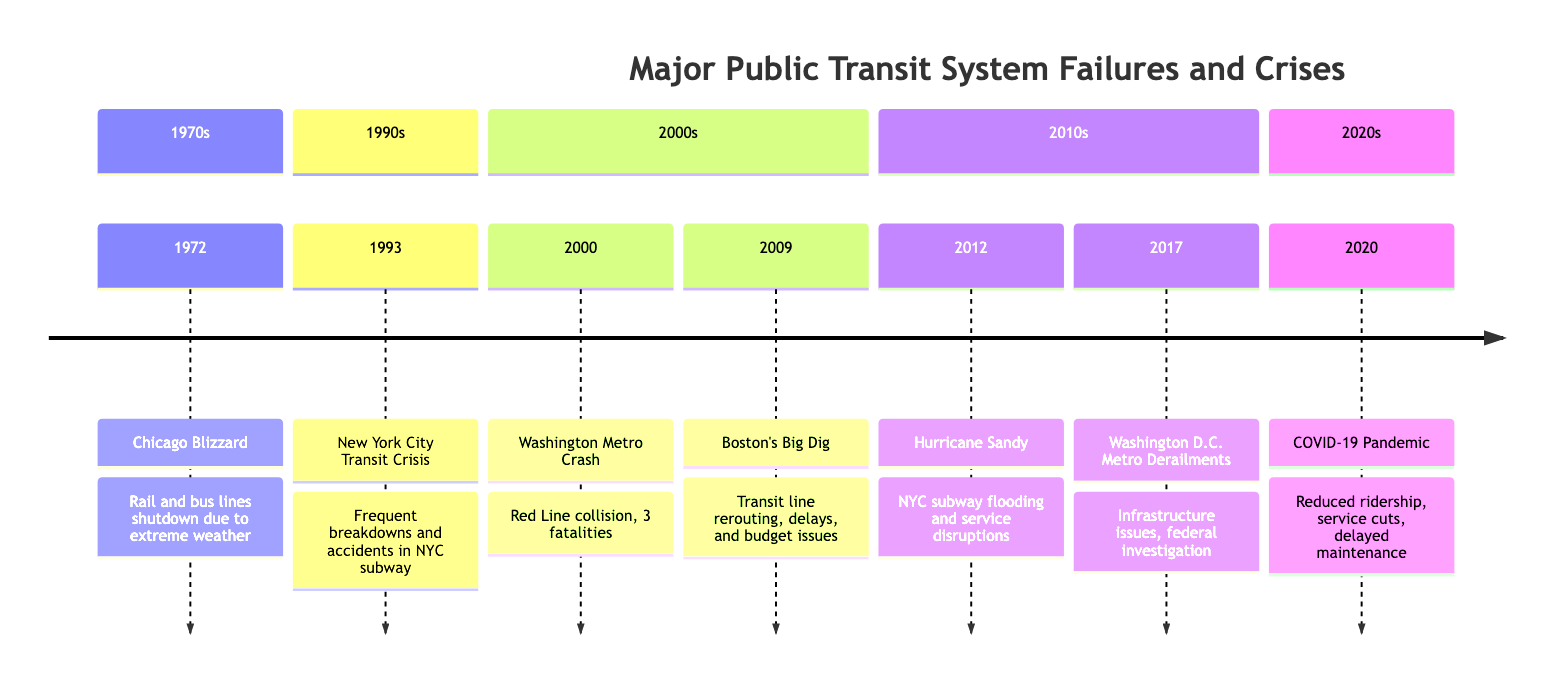What event occurred in 1972? The diagram shows that the event in 1972 is the Chicago Blizzard. This can be directly identified from the timeline as the first entry listed.
Answer: Chicago Blizzard What crisis happened in New York City in 1993? In 1993, the timeline specifies the New York City Transit Crisis. This event is clearly labeled in the timeline for that year.
Answer: New York City Transit Crisis How many fatalities were reported in the 2000 Washington Metro Crash? The event in 2000 details that there were three fatalities due to the Washington Metro Crash, which is directly stated in the description of the event.
Answer: 3 What natural disaster affected New York City Transit in 2012? The diagram states that Hurricane Sandy caused significant flooding in the NYC subway system in 2012. This is the natural disaster noted in that year.
Answer: Hurricane Sandy What was the major issue revealed by the Washington D.C. Metro Derailments in 2017? The timeline notes that the derailments revealed severe infrastructure degradation in the Washington D.C. Metro system, indicating significant failure in maintaining safety protocols.
Answer: Infrastructure degradation Which event led to public outcry in Boston in 2009? The entry for 2009 mentions the Big Dig project and its resulting delays and budget issues. This situation led to a public outcry, as described in the timeline.
Answer: Boston's Big Dig What was a common factor during the crises from 2000 to 2020? Analyzing the entries from 2000 to 2020, a common factor noted is a significant failure in safety and reliability of public transit systems leading to public dissatisfaction, which is a recurring theme across events.
Answer: Safety and reliability failures Which two events specifically highlight infrastructure issues? Focusing on the descriptions, both the Washington Metro Crash in 2000 and the Washington D.C. Metro Derailments in 2017 specify infrastructure issues, underscoring vulnerabilities in their systems.
Answer: Washington Metro Crash and Washington D.C. Metro Derailments What was the effect of the COVID-19 Pandemic on public transit? The timeline entry for 2020 indicates a drastic drop in ridership and revenue due to COVID-19, ultimately forcing service reductions and delayed maintenance, highlighting the pandemic's impact on public transit systems.
Answer: Reduced ridership and service cuts 